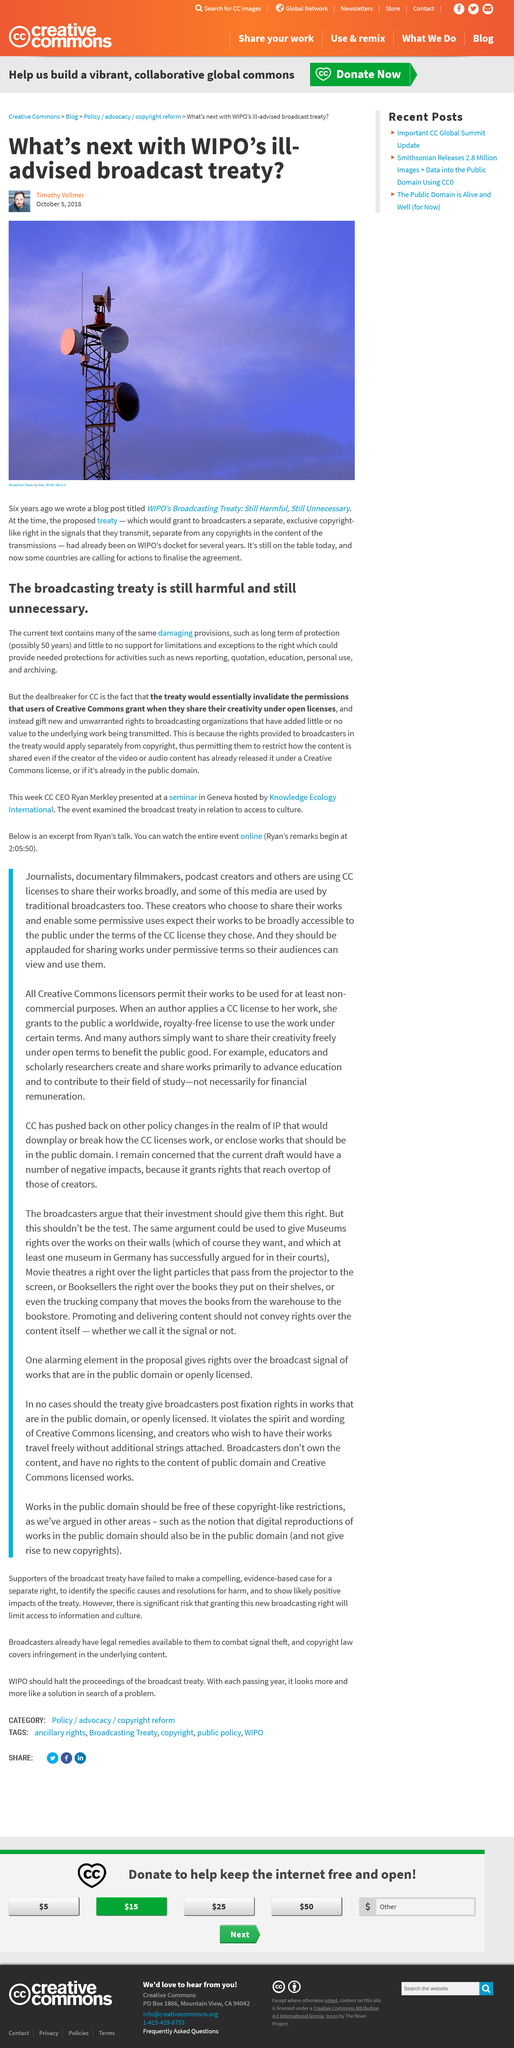Identify some key points in this picture. It is clear that the author of this article is Timothy Vollmer. If broadcasting organizations are granted rights to open licensed works, they may restrict how the content is shared. The author views the WIPO broadcasting treaty as negative, as it is described in the titles as "ill-advised" and "still harmful, still unnecessary. The CC believes that the broadcasting treaty is still harmful and unnecessary and would invalidate open licenses permissions. The photo depicts a broadcast tower, clearly visible in the foreground of the image. 